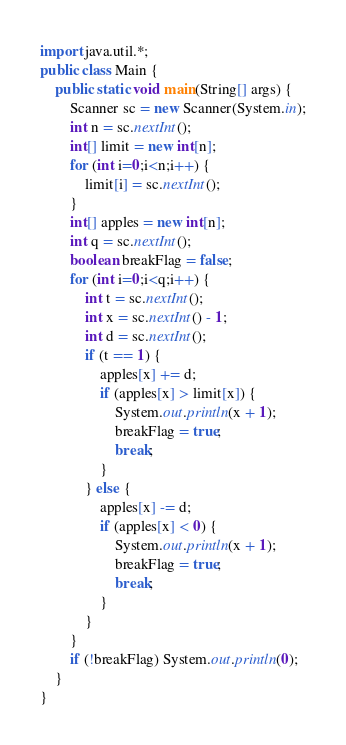Convert code to text. <code><loc_0><loc_0><loc_500><loc_500><_Java_>import java.util.*;
public class Main {
	public static void main(String[] args) {
		Scanner sc = new Scanner(System.in);
		int n = sc.nextInt();
		int[] limit = new int[n];
		for (int i=0;i<n;i++) {
			limit[i] = sc.nextInt();
		}
		int[] apples = new int[n];
		int q = sc.nextInt();
		boolean breakFlag = false;
		for (int i=0;i<q;i++) {
			int t = sc.nextInt();
			int x = sc.nextInt() - 1;
			int d = sc.nextInt();
			if (t == 1) {
				apples[x] += d;
				if (apples[x] > limit[x]) {
					System.out.println(x + 1);
					breakFlag = true;
					break;
				}
			} else {
				apples[x] -= d;
				if (apples[x] < 0) {
					System.out.println(x + 1);
					breakFlag = true;
					break;
				}
			}
		}
		if (!breakFlag) System.out.println(0);
	}
}
</code> 